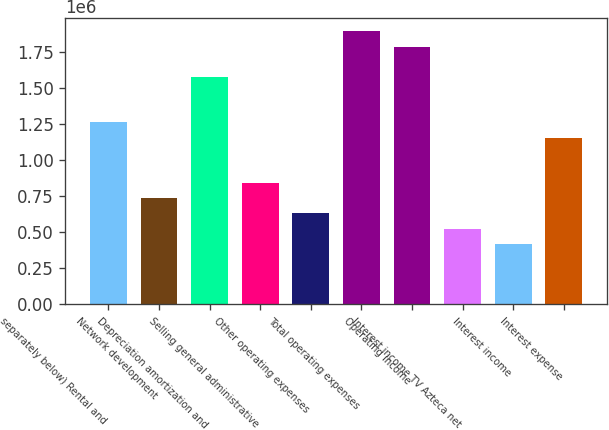Convert chart to OTSL. <chart><loc_0><loc_0><loc_500><loc_500><bar_chart><fcel>separately below) Rental and<fcel>Network development<fcel>Depreciation amortization and<fcel>Selling general administrative<fcel>Other operating expenses<fcel>Total operating expenses<fcel>Operating income<fcel>Interest income TV Azteca net<fcel>Interest income<fcel>Interest expense<nl><fcel>1.26223e+06<fcel>736299<fcel>1.57778e+06<fcel>841485<fcel>631114<fcel>1.89334e+06<fcel>1.78815e+06<fcel>525928<fcel>420743<fcel>1.15704e+06<nl></chart> 